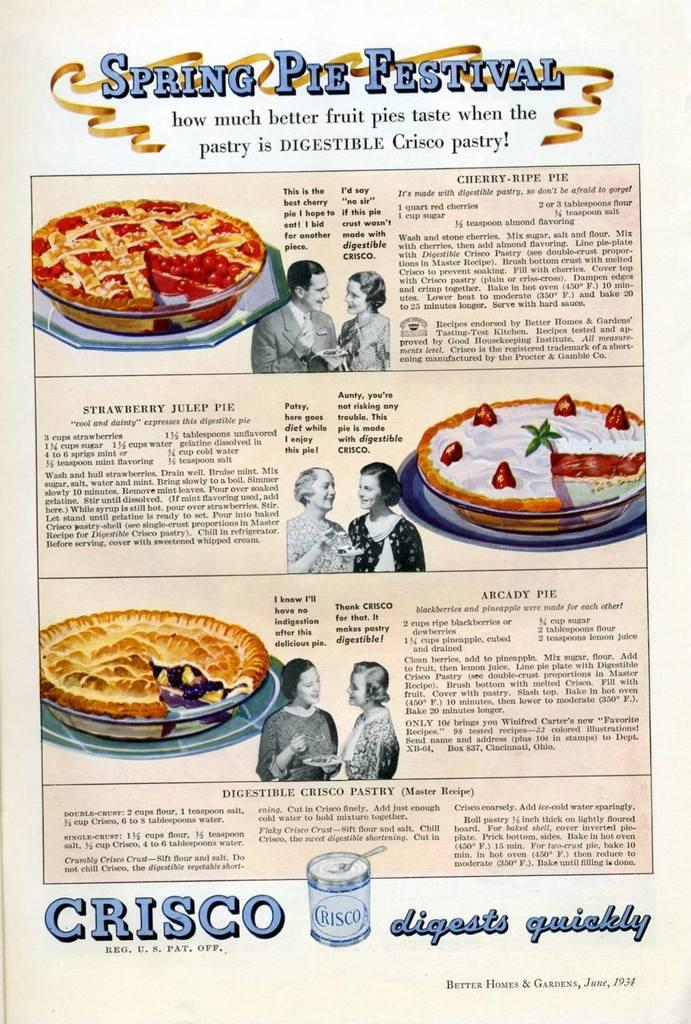What is featured in the picture? There is a poster in the picture. What can be found on the poster? The poster contains text and pictures of a human and food items. What type of credit can be seen on the poster? There is no credit or financial information present on the poster; it contains text, pictures of a human, and pictures of food items. 